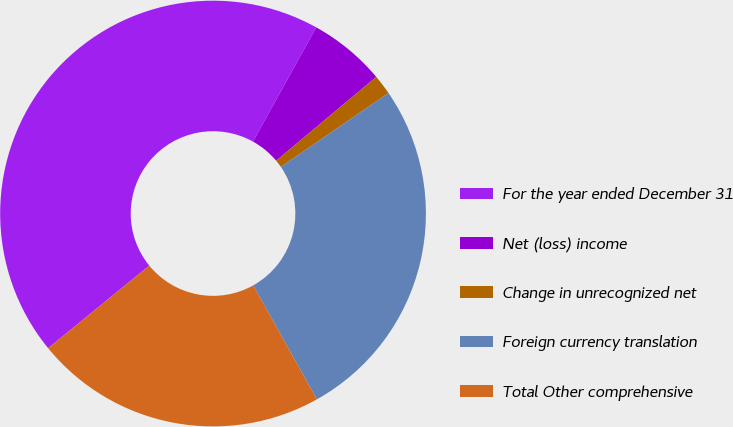<chart> <loc_0><loc_0><loc_500><loc_500><pie_chart><fcel>For the year ended December 31<fcel>Net (loss) income<fcel>Change in unrecognized net<fcel>Foreign currency translation<fcel>Total Other comprehensive<nl><fcel>43.96%<fcel>5.85%<fcel>1.51%<fcel>26.47%<fcel>22.22%<nl></chart> 